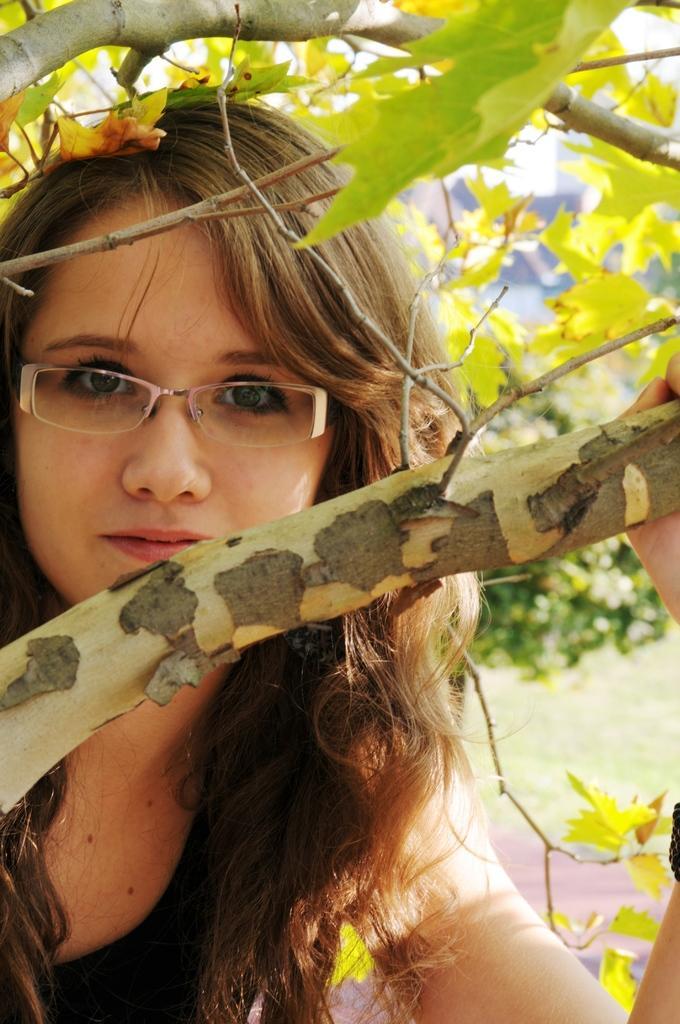Please provide a concise description of this image. In this image I can see a person standing wearing black color dress, background I can see trees in green color and sky in white color. 